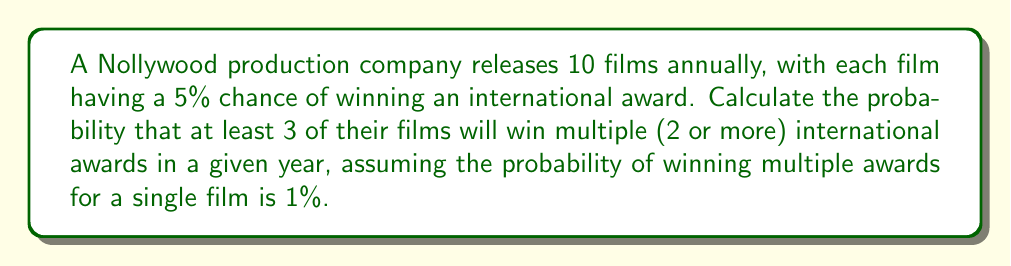Can you answer this question? Let's approach this step-by-step:

1) First, we need to calculate the probability of a single film winning multiple awards. This is given as 1% or 0.01.

2) We can model this scenario using a binomial distribution, where:
   n = 10 (number of films)
   p = 0.01 (probability of success for each film)
   k ≥ 3 (we want at least 3 successes)

3) The probability of at least 3 successes is equal to 1 minus the probability of 0, 1, or 2 successes:

   $$P(X \geq 3) = 1 - [P(X=0) + P(X=1) + P(X=2)]$$

4) We can calculate each of these probabilities using the binomial probability formula:

   $$P(X=k) = \binom{n}{k} p^k (1-p)^{n-k}$$

5) Let's calculate each term:

   $$P(X=0) = \binom{10}{0} (0.01)^0 (0.99)^{10} \approx 0.9043821$$
   
   $$P(X=1) = \binom{10}{1} (0.01)^1 (0.99)^9 \approx 0.0913931$$
   
   $$P(X=2) = \binom{10}{2} (0.01)^2 (0.99)^8 \approx 0.0041542$$

6) Now, we can sum these probabilities and subtract from 1:

   $$P(X \geq 3) = 1 - (0.9043821 + 0.0913931 + 0.0041542)$$
   $$P(X \geq 3) = 1 - 0.9999294 = 0.0000706$$

7) Converting to a percentage:

   $$0.0000706 \times 100\% = 0.00706\%$$
Answer: 0.00706% 